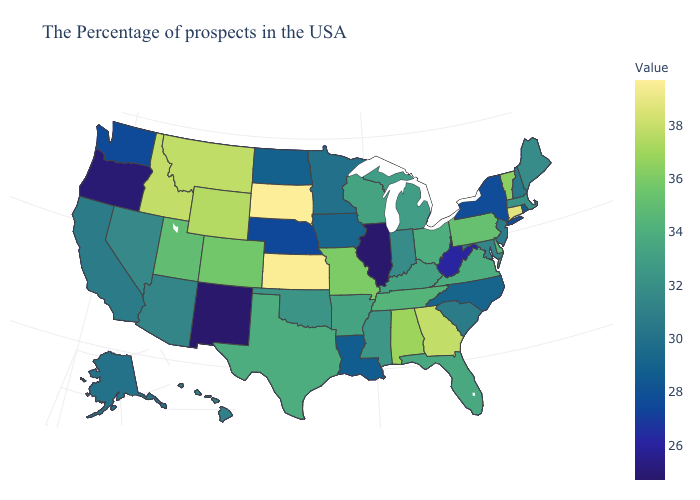Among the states that border Missouri , does Illinois have the highest value?
Quick response, please. No. Does Utah have a higher value than New Hampshire?
Be succinct. Yes. Does Arizona have the lowest value in the West?
Give a very brief answer. No. 